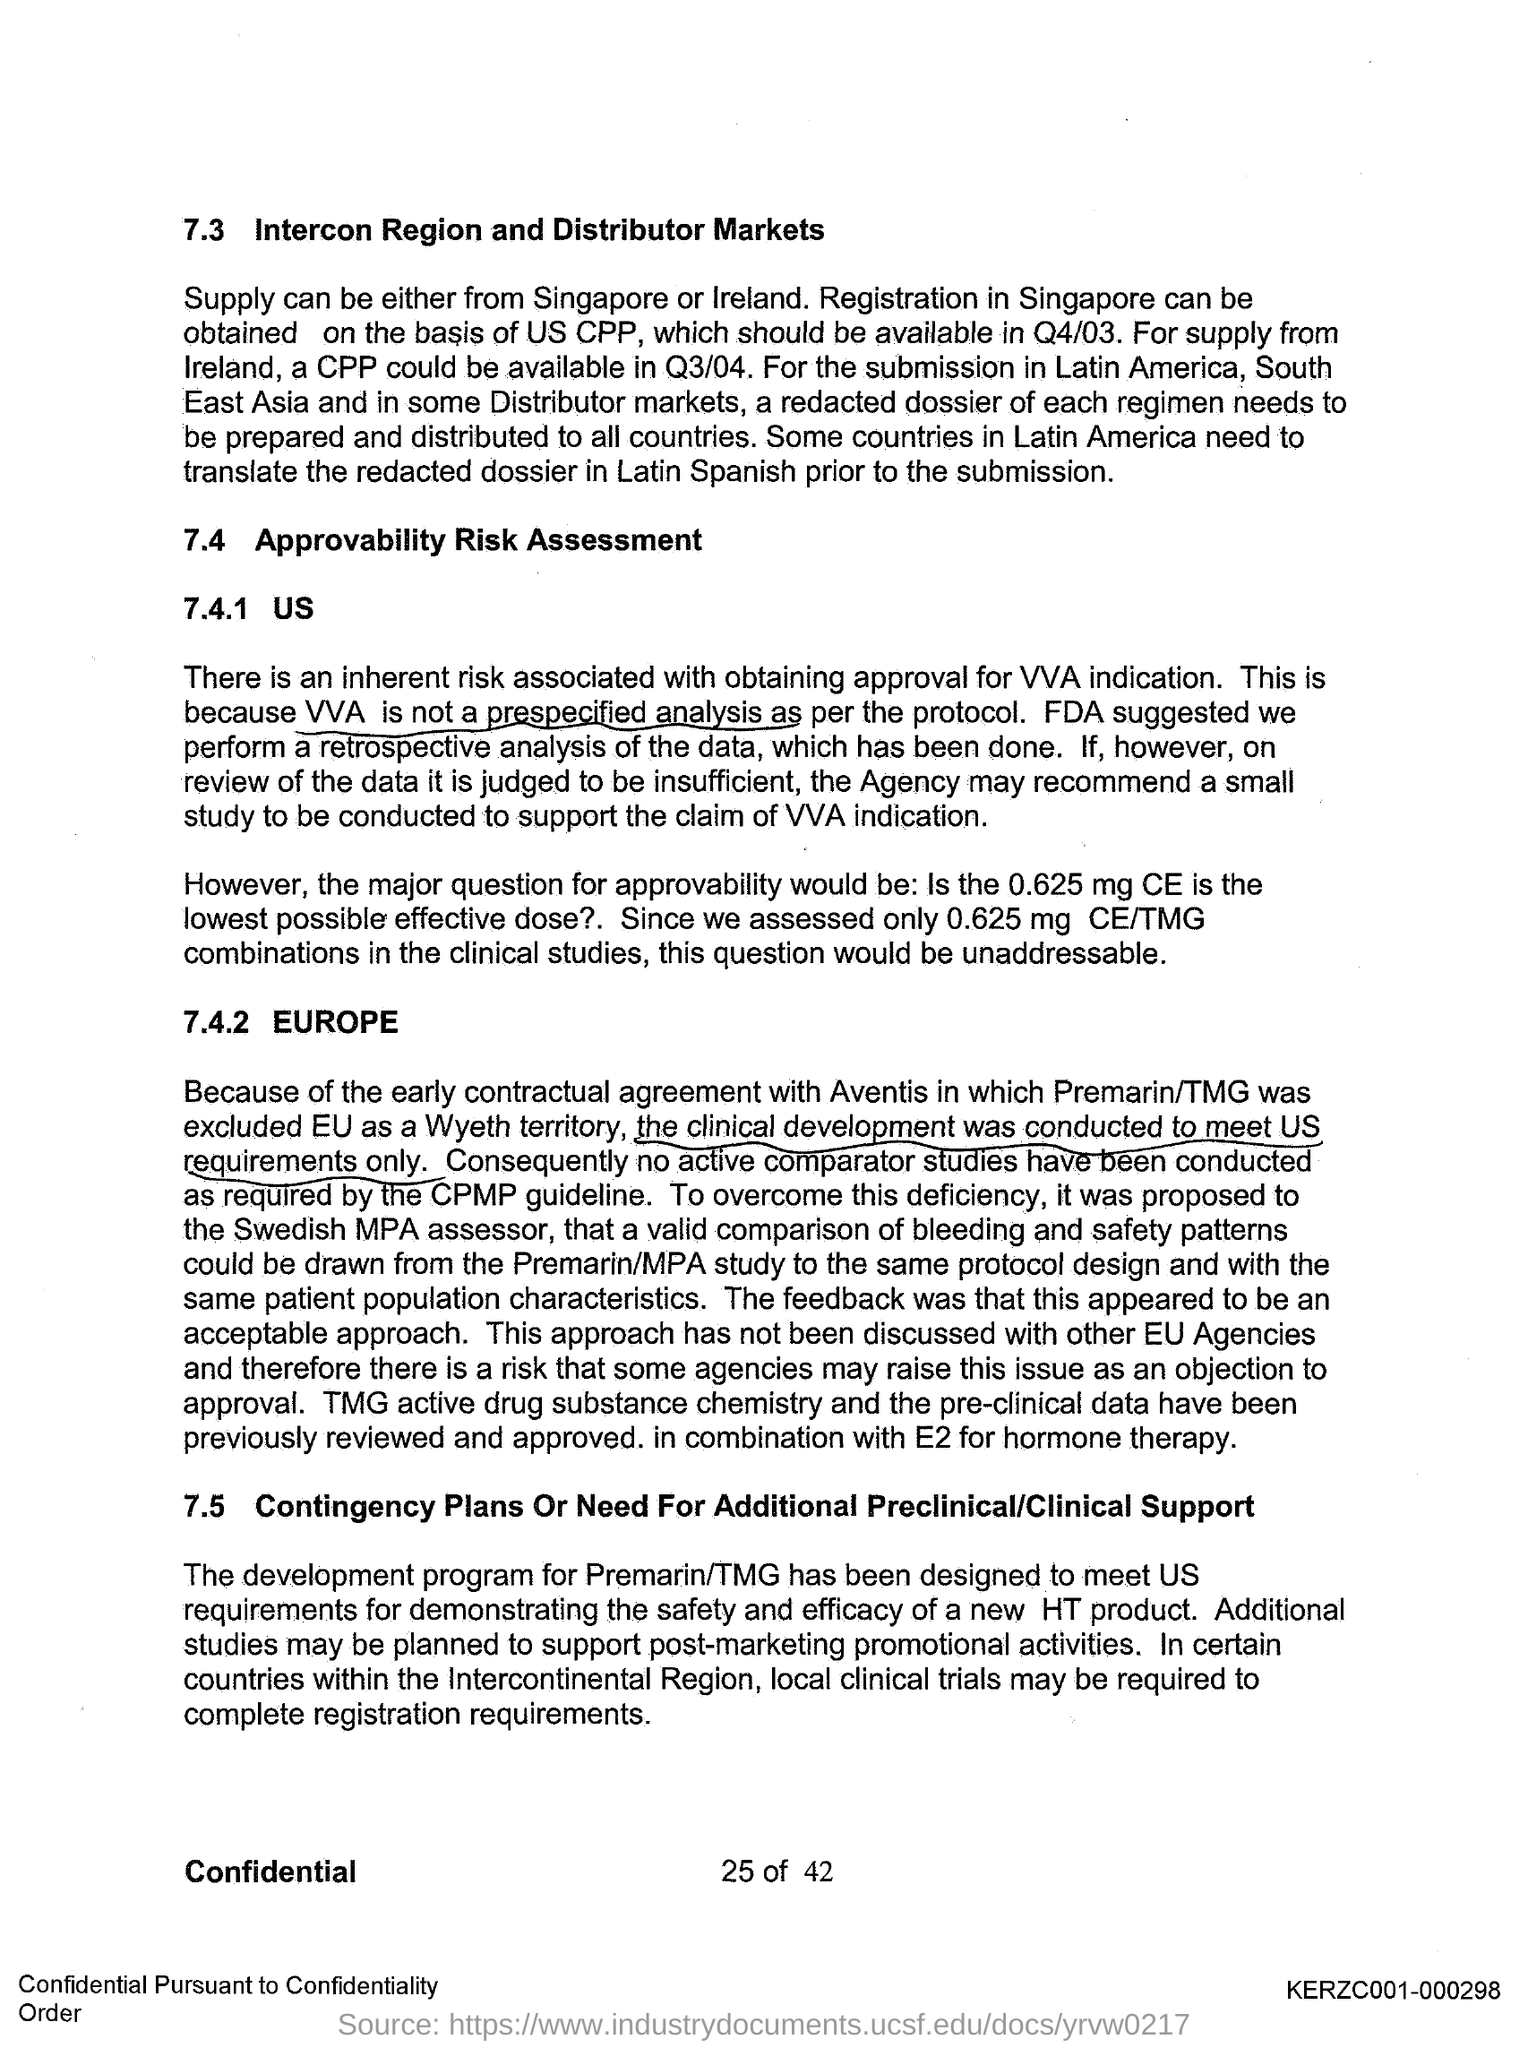Mention a couple of crucial points in this snapshot. The first title in the document is 'Intercon Region and Distributor Markets.' 